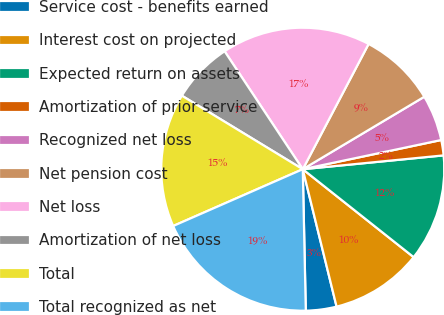<chart> <loc_0><loc_0><loc_500><loc_500><pie_chart><fcel>Service cost - benefits earned<fcel>Interest cost on projected<fcel>Expected return on assets<fcel>Amortization of prior service<fcel>Recognized net loss<fcel>Net pension cost<fcel>Net loss<fcel>Amortization of net loss<fcel>Total<fcel>Total recognized as net<nl><fcel>3.5%<fcel>10.49%<fcel>12.23%<fcel>1.75%<fcel>5.25%<fcel>8.74%<fcel>17.02%<fcel>6.99%<fcel>15.27%<fcel>18.77%<nl></chart> 